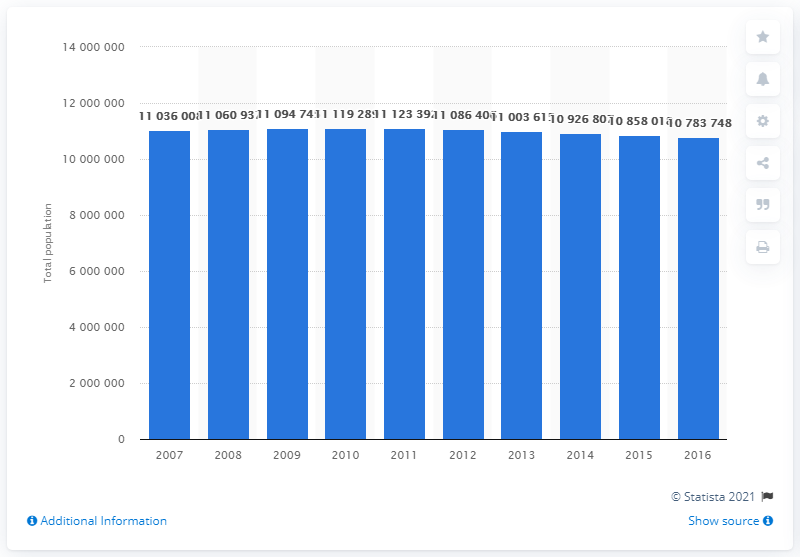Point out several critical features in this image. In 2016, the population of Greece was 10,783,748. 